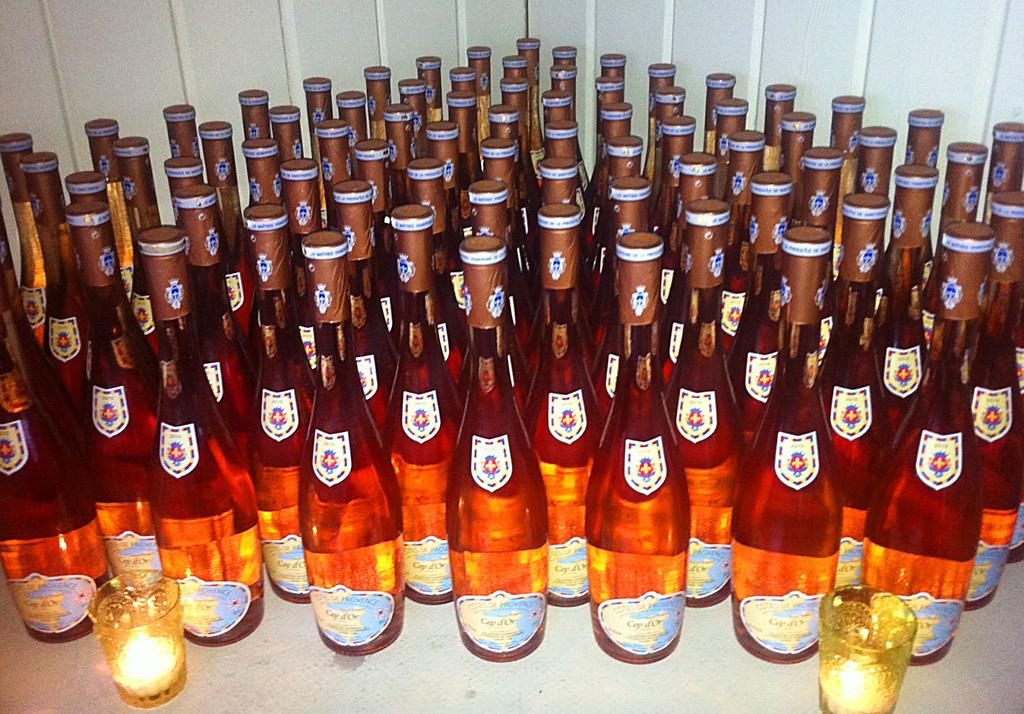What objects are present in the image that are typically used for holding liquids? There are bottles and glasses in the image that are typically used for holding liquids. What type of trousers are visible in the image? There are no trousers present in the image. How many bodies can be seen in the image? There are no bodies present in the image. 